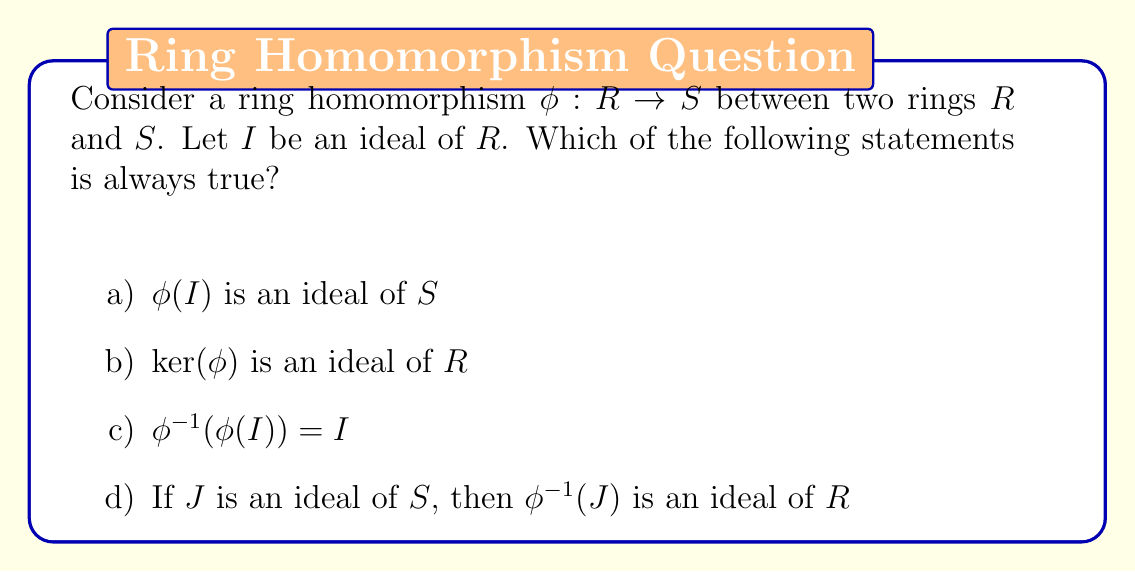Provide a solution to this math problem. Let's examine each option:

a) $\phi(I)$ is an ideal of $S$
This is not always true. While $\phi(I)$ is always a subring of $S$, it may not be closed under multiplication by elements of $S$. For example, if $\phi$ is not surjective, there might be elements in $S$ that are not in the image of $\phi$.

b) $\ker(\phi)$ is an ideal of $R$
This is always true. Let's prove it:
1) $\ker(\phi) = \{r \in R : \phi(r) = 0_S\}$
2) For any $a,b \in \ker(\phi)$, $\phi(a-b) = \phi(a) - \phi(b) = 0_S - 0_S = 0_S$, so $a-b \in \ker(\phi)$
3) For any $r \in R$ and $a \in \ker(\phi)$, $\phi(ra) = \phi(r)\phi(a) = \phi(r) \cdot 0_S = 0_S$, so $ra \in \ker(\phi)$
4) Similarly, $\phi(ar) = \phi(a)\phi(r) = 0_S \cdot \phi(r) = 0_S$, so $ar \in \ker(\phi)$
Therefore, $\ker(\phi)$ satisfies all conditions to be an ideal of $R$.

c) $\phi^{-1}(\phi(I)) = I$
This is not always true. We always have $I \subseteq \phi^{-1}(\phi(I))$, but equality holds only if $\phi$ is injective on $I$.

d) If $J$ is an ideal of $S$, then $\phi^{-1}(J)$ is an ideal of $R$
This is always true. Let's prove it:
1) For any $a,b \in \phi^{-1}(J)$, $\phi(a-b) = \phi(a) - \phi(b) \in J$ (since $J$ is an ideal), so $a-b \in \phi^{-1}(J)$
2) For any $r \in R$ and $a \in \phi^{-1}(J)$, $\phi(ra) = \phi(r)\phi(a) \in J$ (since $J$ is an ideal), so $ra \in \phi^{-1}(J)$
3) Similarly, $\phi(ar) = \phi(a)\phi(r) \in J$, so $ar \in \phi^{-1}(J)$
Therefore, $\phi^{-1}(J)$ satisfies all conditions to be an ideal of $R$.
Answer: The correct answer is: b) and d) are always true. 